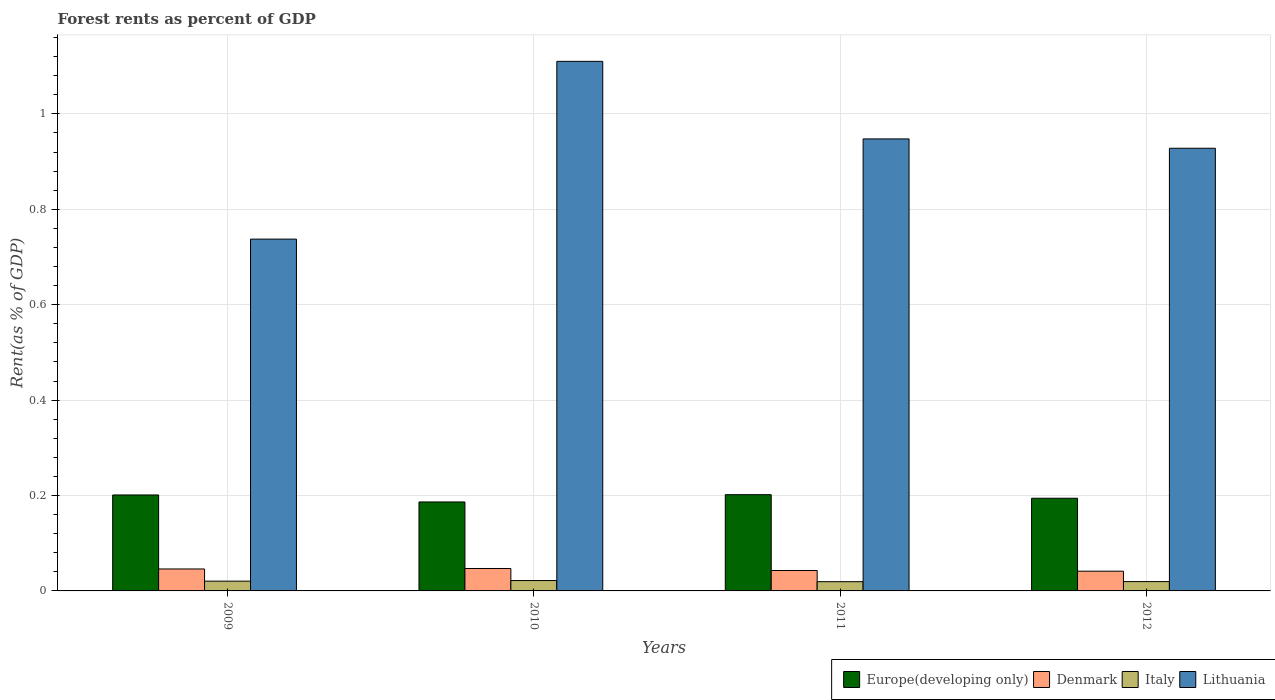How many groups of bars are there?
Provide a succinct answer. 4. Are the number of bars on each tick of the X-axis equal?
Offer a very short reply. Yes. How many bars are there on the 1st tick from the left?
Offer a very short reply. 4. What is the forest rent in Europe(developing only) in 2012?
Offer a very short reply. 0.19. Across all years, what is the maximum forest rent in Lithuania?
Offer a very short reply. 1.11. Across all years, what is the minimum forest rent in Italy?
Give a very brief answer. 0.02. In which year was the forest rent in Europe(developing only) maximum?
Offer a very short reply. 2011. What is the total forest rent in Europe(developing only) in the graph?
Ensure brevity in your answer.  0.78. What is the difference between the forest rent in Italy in 2009 and that in 2010?
Offer a terse response. -0. What is the difference between the forest rent in Italy in 2011 and the forest rent in Europe(developing only) in 2012?
Provide a succinct answer. -0.17. What is the average forest rent in Lithuania per year?
Your answer should be compact. 0.93. In the year 2011, what is the difference between the forest rent in Denmark and forest rent in Italy?
Your answer should be compact. 0.02. In how many years, is the forest rent in Europe(developing only) greater than 0.04 %?
Offer a very short reply. 4. What is the ratio of the forest rent in Denmark in 2009 to that in 2010?
Provide a short and direct response. 0.98. What is the difference between the highest and the second highest forest rent in Europe(developing only)?
Keep it short and to the point. 0. What is the difference between the highest and the lowest forest rent in Italy?
Offer a very short reply. 0. Is the sum of the forest rent in Italy in 2010 and 2012 greater than the maximum forest rent in Denmark across all years?
Provide a succinct answer. No. Is it the case that in every year, the sum of the forest rent in Italy and forest rent in Lithuania is greater than the sum of forest rent in Denmark and forest rent in Europe(developing only)?
Your response must be concise. Yes. What does the 2nd bar from the right in 2011 represents?
Your answer should be very brief. Italy. Are the values on the major ticks of Y-axis written in scientific E-notation?
Keep it short and to the point. No. Where does the legend appear in the graph?
Offer a terse response. Bottom right. How many legend labels are there?
Provide a succinct answer. 4. What is the title of the graph?
Provide a succinct answer. Forest rents as percent of GDP. What is the label or title of the Y-axis?
Your answer should be very brief. Rent(as % of GDP). What is the Rent(as % of GDP) of Europe(developing only) in 2009?
Give a very brief answer. 0.2. What is the Rent(as % of GDP) of Denmark in 2009?
Keep it short and to the point. 0.05. What is the Rent(as % of GDP) of Italy in 2009?
Your answer should be very brief. 0.02. What is the Rent(as % of GDP) in Lithuania in 2009?
Keep it short and to the point. 0.74. What is the Rent(as % of GDP) in Europe(developing only) in 2010?
Give a very brief answer. 0.19. What is the Rent(as % of GDP) of Denmark in 2010?
Your answer should be very brief. 0.05. What is the Rent(as % of GDP) in Italy in 2010?
Provide a succinct answer. 0.02. What is the Rent(as % of GDP) in Lithuania in 2010?
Provide a short and direct response. 1.11. What is the Rent(as % of GDP) in Europe(developing only) in 2011?
Keep it short and to the point. 0.2. What is the Rent(as % of GDP) in Denmark in 2011?
Your answer should be compact. 0.04. What is the Rent(as % of GDP) in Italy in 2011?
Offer a terse response. 0.02. What is the Rent(as % of GDP) of Lithuania in 2011?
Keep it short and to the point. 0.95. What is the Rent(as % of GDP) in Europe(developing only) in 2012?
Provide a succinct answer. 0.19. What is the Rent(as % of GDP) of Denmark in 2012?
Your response must be concise. 0.04. What is the Rent(as % of GDP) of Italy in 2012?
Your answer should be compact. 0.02. What is the Rent(as % of GDP) of Lithuania in 2012?
Keep it short and to the point. 0.93. Across all years, what is the maximum Rent(as % of GDP) in Europe(developing only)?
Provide a succinct answer. 0.2. Across all years, what is the maximum Rent(as % of GDP) in Denmark?
Offer a terse response. 0.05. Across all years, what is the maximum Rent(as % of GDP) in Italy?
Ensure brevity in your answer.  0.02. Across all years, what is the maximum Rent(as % of GDP) of Lithuania?
Ensure brevity in your answer.  1.11. Across all years, what is the minimum Rent(as % of GDP) of Europe(developing only)?
Your response must be concise. 0.19. Across all years, what is the minimum Rent(as % of GDP) in Denmark?
Keep it short and to the point. 0.04. Across all years, what is the minimum Rent(as % of GDP) in Italy?
Keep it short and to the point. 0.02. Across all years, what is the minimum Rent(as % of GDP) in Lithuania?
Your answer should be very brief. 0.74. What is the total Rent(as % of GDP) of Europe(developing only) in the graph?
Make the answer very short. 0.78. What is the total Rent(as % of GDP) in Denmark in the graph?
Your answer should be compact. 0.18. What is the total Rent(as % of GDP) of Italy in the graph?
Give a very brief answer. 0.08. What is the total Rent(as % of GDP) in Lithuania in the graph?
Give a very brief answer. 3.72. What is the difference between the Rent(as % of GDP) in Europe(developing only) in 2009 and that in 2010?
Ensure brevity in your answer.  0.01. What is the difference between the Rent(as % of GDP) in Denmark in 2009 and that in 2010?
Offer a terse response. -0. What is the difference between the Rent(as % of GDP) of Italy in 2009 and that in 2010?
Your answer should be very brief. -0. What is the difference between the Rent(as % of GDP) of Lithuania in 2009 and that in 2010?
Provide a succinct answer. -0.37. What is the difference between the Rent(as % of GDP) in Europe(developing only) in 2009 and that in 2011?
Keep it short and to the point. -0. What is the difference between the Rent(as % of GDP) of Denmark in 2009 and that in 2011?
Offer a very short reply. 0. What is the difference between the Rent(as % of GDP) in Italy in 2009 and that in 2011?
Offer a terse response. 0. What is the difference between the Rent(as % of GDP) in Lithuania in 2009 and that in 2011?
Ensure brevity in your answer.  -0.21. What is the difference between the Rent(as % of GDP) of Europe(developing only) in 2009 and that in 2012?
Give a very brief answer. 0.01. What is the difference between the Rent(as % of GDP) of Denmark in 2009 and that in 2012?
Offer a very short reply. 0. What is the difference between the Rent(as % of GDP) in Italy in 2009 and that in 2012?
Offer a very short reply. 0. What is the difference between the Rent(as % of GDP) in Lithuania in 2009 and that in 2012?
Offer a terse response. -0.19. What is the difference between the Rent(as % of GDP) in Europe(developing only) in 2010 and that in 2011?
Keep it short and to the point. -0.02. What is the difference between the Rent(as % of GDP) in Denmark in 2010 and that in 2011?
Ensure brevity in your answer.  0. What is the difference between the Rent(as % of GDP) in Italy in 2010 and that in 2011?
Give a very brief answer. 0. What is the difference between the Rent(as % of GDP) in Lithuania in 2010 and that in 2011?
Your answer should be compact. 0.16. What is the difference between the Rent(as % of GDP) of Europe(developing only) in 2010 and that in 2012?
Provide a short and direct response. -0.01. What is the difference between the Rent(as % of GDP) of Denmark in 2010 and that in 2012?
Your answer should be compact. 0.01. What is the difference between the Rent(as % of GDP) in Italy in 2010 and that in 2012?
Your answer should be very brief. 0. What is the difference between the Rent(as % of GDP) in Lithuania in 2010 and that in 2012?
Give a very brief answer. 0.18. What is the difference between the Rent(as % of GDP) in Europe(developing only) in 2011 and that in 2012?
Keep it short and to the point. 0.01. What is the difference between the Rent(as % of GDP) of Denmark in 2011 and that in 2012?
Ensure brevity in your answer.  0. What is the difference between the Rent(as % of GDP) in Italy in 2011 and that in 2012?
Make the answer very short. -0. What is the difference between the Rent(as % of GDP) of Lithuania in 2011 and that in 2012?
Your response must be concise. 0.02. What is the difference between the Rent(as % of GDP) in Europe(developing only) in 2009 and the Rent(as % of GDP) in Denmark in 2010?
Offer a very short reply. 0.15. What is the difference between the Rent(as % of GDP) of Europe(developing only) in 2009 and the Rent(as % of GDP) of Italy in 2010?
Keep it short and to the point. 0.18. What is the difference between the Rent(as % of GDP) in Europe(developing only) in 2009 and the Rent(as % of GDP) in Lithuania in 2010?
Provide a succinct answer. -0.91. What is the difference between the Rent(as % of GDP) in Denmark in 2009 and the Rent(as % of GDP) in Italy in 2010?
Your answer should be very brief. 0.02. What is the difference between the Rent(as % of GDP) in Denmark in 2009 and the Rent(as % of GDP) in Lithuania in 2010?
Your answer should be very brief. -1.06. What is the difference between the Rent(as % of GDP) of Italy in 2009 and the Rent(as % of GDP) of Lithuania in 2010?
Make the answer very short. -1.09. What is the difference between the Rent(as % of GDP) of Europe(developing only) in 2009 and the Rent(as % of GDP) of Denmark in 2011?
Offer a terse response. 0.16. What is the difference between the Rent(as % of GDP) of Europe(developing only) in 2009 and the Rent(as % of GDP) of Italy in 2011?
Offer a very short reply. 0.18. What is the difference between the Rent(as % of GDP) of Europe(developing only) in 2009 and the Rent(as % of GDP) of Lithuania in 2011?
Offer a terse response. -0.75. What is the difference between the Rent(as % of GDP) in Denmark in 2009 and the Rent(as % of GDP) in Italy in 2011?
Keep it short and to the point. 0.03. What is the difference between the Rent(as % of GDP) in Denmark in 2009 and the Rent(as % of GDP) in Lithuania in 2011?
Your answer should be compact. -0.9. What is the difference between the Rent(as % of GDP) in Italy in 2009 and the Rent(as % of GDP) in Lithuania in 2011?
Give a very brief answer. -0.93. What is the difference between the Rent(as % of GDP) in Europe(developing only) in 2009 and the Rent(as % of GDP) in Denmark in 2012?
Make the answer very short. 0.16. What is the difference between the Rent(as % of GDP) of Europe(developing only) in 2009 and the Rent(as % of GDP) of Italy in 2012?
Ensure brevity in your answer.  0.18. What is the difference between the Rent(as % of GDP) of Europe(developing only) in 2009 and the Rent(as % of GDP) of Lithuania in 2012?
Ensure brevity in your answer.  -0.73. What is the difference between the Rent(as % of GDP) in Denmark in 2009 and the Rent(as % of GDP) in Italy in 2012?
Your answer should be very brief. 0.03. What is the difference between the Rent(as % of GDP) of Denmark in 2009 and the Rent(as % of GDP) of Lithuania in 2012?
Provide a succinct answer. -0.88. What is the difference between the Rent(as % of GDP) of Italy in 2009 and the Rent(as % of GDP) of Lithuania in 2012?
Give a very brief answer. -0.91. What is the difference between the Rent(as % of GDP) of Europe(developing only) in 2010 and the Rent(as % of GDP) of Denmark in 2011?
Ensure brevity in your answer.  0.14. What is the difference between the Rent(as % of GDP) of Europe(developing only) in 2010 and the Rent(as % of GDP) of Italy in 2011?
Your response must be concise. 0.17. What is the difference between the Rent(as % of GDP) in Europe(developing only) in 2010 and the Rent(as % of GDP) in Lithuania in 2011?
Offer a terse response. -0.76. What is the difference between the Rent(as % of GDP) in Denmark in 2010 and the Rent(as % of GDP) in Italy in 2011?
Provide a short and direct response. 0.03. What is the difference between the Rent(as % of GDP) in Denmark in 2010 and the Rent(as % of GDP) in Lithuania in 2011?
Offer a very short reply. -0.9. What is the difference between the Rent(as % of GDP) of Italy in 2010 and the Rent(as % of GDP) of Lithuania in 2011?
Offer a very short reply. -0.93. What is the difference between the Rent(as % of GDP) in Europe(developing only) in 2010 and the Rent(as % of GDP) in Denmark in 2012?
Make the answer very short. 0.15. What is the difference between the Rent(as % of GDP) of Europe(developing only) in 2010 and the Rent(as % of GDP) of Italy in 2012?
Ensure brevity in your answer.  0.17. What is the difference between the Rent(as % of GDP) in Europe(developing only) in 2010 and the Rent(as % of GDP) in Lithuania in 2012?
Offer a very short reply. -0.74. What is the difference between the Rent(as % of GDP) of Denmark in 2010 and the Rent(as % of GDP) of Italy in 2012?
Keep it short and to the point. 0.03. What is the difference between the Rent(as % of GDP) of Denmark in 2010 and the Rent(as % of GDP) of Lithuania in 2012?
Your answer should be very brief. -0.88. What is the difference between the Rent(as % of GDP) of Italy in 2010 and the Rent(as % of GDP) of Lithuania in 2012?
Your response must be concise. -0.91. What is the difference between the Rent(as % of GDP) of Europe(developing only) in 2011 and the Rent(as % of GDP) of Denmark in 2012?
Keep it short and to the point. 0.16. What is the difference between the Rent(as % of GDP) of Europe(developing only) in 2011 and the Rent(as % of GDP) of Italy in 2012?
Give a very brief answer. 0.18. What is the difference between the Rent(as % of GDP) in Europe(developing only) in 2011 and the Rent(as % of GDP) in Lithuania in 2012?
Give a very brief answer. -0.73. What is the difference between the Rent(as % of GDP) in Denmark in 2011 and the Rent(as % of GDP) in Italy in 2012?
Offer a terse response. 0.02. What is the difference between the Rent(as % of GDP) of Denmark in 2011 and the Rent(as % of GDP) of Lithuania in 2012?
Ensure brevity in your answer.  -0.89. What is the difference between the Rent(as % of GDP) of Italy in 2011 and the Rent(as % of GDP) of Lithuania in 2012?
Your response must be concise. -0.91. What is the average Rent(as % of GDP) in Europe(developing only) per year?
Provide a short and direct response. 0.2. What is the average Rent(as % of GDP) of Denmark per year?
Give a very brief answer. 0.04. What is the average Rent(as % of GDP) in Italy per year?
Make the answer very short. 0.02. What is the average Rent(as % of GDP) in Lithuania per year?
Give a very brief answer. 0.93. In the year 2009, what is the difference between the Rent(as % of GDP) of Europe(developing only) and Rent(as % of GDP) of Denmark?
Your answer should be very brief. 0.16. In the year 2009, what is the difference between the Rent(as % of GDP) of Europe(developing only) and Rent(as % of GDP) of Italy?
Ensure brevity in your answer.  0.18. In the year 2009, what is the difference between the Rent(as % of GDP) in Europe(developing only) and Rent(as % of GDP) in Lithuania?
Ensure brevity in your answer.  -0.54. In the year 2009, what is the difference between the Rent(as % of GDP) in Denmark and Rent(as % of GDP) in Italy?
Keep it short and to the point. 0.03. In the year 2009, what is the difference between the Rent(as % of GDP) in Denmark and Rent(as % of GDP) in Lithuania?
Provide a short and direct response. -0.69. In the year 2009, what is the difference between the Rent(as % of GDP) in Italy and Rent(as % of GDP) in Lithuania?
Ensure brevity in your answer.  -0.72. In the year 2010, what is the difference between the Rent(as % of GDP) in Europe(developing only) and Rent(as % of GDP) in Denmark?
Your answer should be compact. 0.14. In the year 2010, what is the difference between the Rent(as % of GDP) in Europe(developing only) and Rent(as % of GDP) in Italy?
Keep it short and to the point. 0.16. In the year 2010, what is the difference between the Rent(as % of GDP) of Europe(developing only) and Rent(as % of GDP) of Lithuania?
Keep it short and to the point. -0.92. In the year 2010, what is the difference between the Rent(as % of GDP) of Denmark and Rent(as % of GDP) of Italy?
Your answer should be compact. 0.03. In the year 2010, what is the difference between the Rent(as % of GDP) in Denmark and Rent(as % of GDP) in Lithuania?
Your response must be concise. -1.06. In the year 2010, what is the difference between the Rent(as % of GDP) of Italy and Rent(as % of GDP) of Lithuania?
Your answer should be compact. -1.09. In the year 2011, what is the difference between the Rent(as % of GDP) in Europe(developing only) and Rent(as % of GDP) in Denmark?
Ensure brevity in your answer.  0.16. In the year 2011, what is the difference between the Rent(as % of GDP) in Europe(developing only) and Rent(as % of GDP) in Italy?
Provide a succinct answer. 0.18. In the year 2011, what is the difference between the Rent(as % of GDP) of Europe(developing only) and Rent(as % of GDP) of Lithuania?
Keep it short and to the point. -0.75. In the year 2011, what is the difference between the Rent(as % of GDP) of Denmark and Rent(as % of GDP) of Italy?
Keep it short and to the point. 0.02. In the year 2011, what is the difference between the Rent(as % of GDP) in Denmark and Rent(as % of GDP) in Lithuania?
Ensure brevity in your answer.  -0.9. In the year 2011, what is the difference between the Rent(as % of GDP) of Italy and Rent(as % of GDP) of Lithuania?
Ensure brevity in your answer.  -0.93. In the year 2012, what is the difference between the Rent(as % of GDP) of Europe(developing only) and Rent(as % of GDP) of Denmark?
Your answer should be very brief. 0.15. In the year 2012, what is the difference between the Rent(as % of GDP) in Europe(developing only) and Rent(as % of GDP) in Italy?
Provide a succinct answer. 0.17. In the year 2012, what is the difference between the Rent(as % of GDP) of Europe(developing only) and Rent(as % of GDP) of Lithuania?
Give a very brief answer. -0.73. In the year 2012, what is the difference between the Rent(as % of GDP) of Denmark and Rent(as % of GDP) of Italy?
Provide a short and direct response. 0.02. In the year 2012, what is the difference between the Rent(as % of GDP) of Denmark and Rent(as % of GDP) of Lithuania?
Give a very brief answer. -0.89. In the year 2012, what is the difference between the Rent(as % of GDP) in Italy and Rent(as % of GDP) in Lithuania?
Give a very brief answer. -0.91. What is the ratio of the Rent(as % of GDP) of Europe(developing only) in 2009 to that in 2010?
Provide a succinct answer. 1.08. What is the ratio of the Rent(as % of GDP) in Denmark in 2009 to that in 2010?
Your answer should be compact. 0.98. What is the ratio of the Rent(as % of GDP) in Italy in 2009 to that in 2010?
Provide a short and direct response. 0.94. What is the ratio of the Rent(as % of GDP) in Lithuania in 2009 to that in 2010?
Make the answer very short. 0.66. What is the ratio of the Rent(as % of GDP) in Europe(developing only) in 2009 to that in 2011?
Your response must be concise. 1. What is the ratio of the Rent(as % of GDP) in Denmark in 2009 to that in 2011?
Keep it short and to the point. 1.07. What is the ratio of the Rent(as % of GDP) of Italy in 2009 to that in 2011?
Provide a short and direct response. 1.06. What is the ratio of the Rent(as % of GDP) in Lithuania in 2009 to that in 2011?
Give a very brief answer. 0.78. What is the ratio of the Rent(as % of GDP) in Europe(developing only) in 2009 to that in 2012?
Ensure brevity in your answer.  1.04. What is the ratio of the Rent(as % of GDP) in Denmark in 2009 to that in 2012?
Your answer should be compact. 1.11. What is the ratio of the Rent(as % of GDP) in Italy in 2009 to that in 2012?
Make the answer very short. 1.05. What is the ratio of the Rent(as % of GDP) in Lithuania in 2009 to that in 2012?
Provide a short and direct response. 0.79. What is the ratio of the Rent(as % of GDP) of Europe(developing only) in 2010 to that in 2011?
Make the answer very short. 0.92. What is the ratio of the Rent(as % of GDP) in Denmark in 2010 to that in 2011?
Your answer should be compact. 1.1. What is the ratio of the Rent(as % of GDP) in Italy in 2010 to that in 2011?
Provide a short and direct response. 1.12. What is the ratio of the Rent(as % of GDP) of Lithuania in 2010 to that in 2011?
Offer a terse response. 1.17. What is the ratio of the Rent(as % of GDP) in Europe(developing only) in 2010 to that in 2012?
Your response must be concise. 0.96. What is the ratio of the Rent(as % of GDP) of Denmark in 2010 to that in 2012?
Offer a very short reply. 1.14. What is the ratio of the Rent(as % of GDP) of Italy in 2010 to that in 2012?
Your response must be concise. 1.11. What is the ratio of the Rent(as % of GDP) of Lithuania in 2010 to that in 2012?
Make the answer very short. 1.2. What is the ratio of the Rent(as % of GDP) of Europe(developing only) in 2011 to that in 2012?
Offer a terse response. 1.04. What is the ratio of the Rent(as % of GDP) of Denmark in 2011 to that in 2012?
Provide a succinct answer. 1.04. What is the ratio of the Rent(as % of GDP) in Lithuania in 2011 to that in 2012?
Give a very brief answer. 1.02. What is the difference between the highest and the second highest Rent(as % of GDP) in Europe(developing only)?
Keep it short and to the point. 0. What is the difference between the highest and the second highest Rent(as % of GDP) in Denmark?
Provide a succinct answer. 0. What is the difference between the highest and the second highest Rent(as % of GDP) in Italy?
Make the answer very short. 0. What is the difference between the highest and the second highest Rent(as % of GDP) in Lithuania?
Offer a very short reply. 0.16. What is the difference between the highest and the lowest Rent(as % of GDP) of Europe(developing only)?
Give a very brief answer. 0.02. What is the difference between the highest and the lowest Rent(as % of GDP) in Denmark?
Offer a very short reply. 0.01. What is the difference between the highest and the lowest Rent(as % of GDP) in Italy?
Provide a short and direct response. 0. What is the difference between the highest and the lowest Rent(as % of GDP) of Lithuania?
Your answer should be very brief. 0.37. 